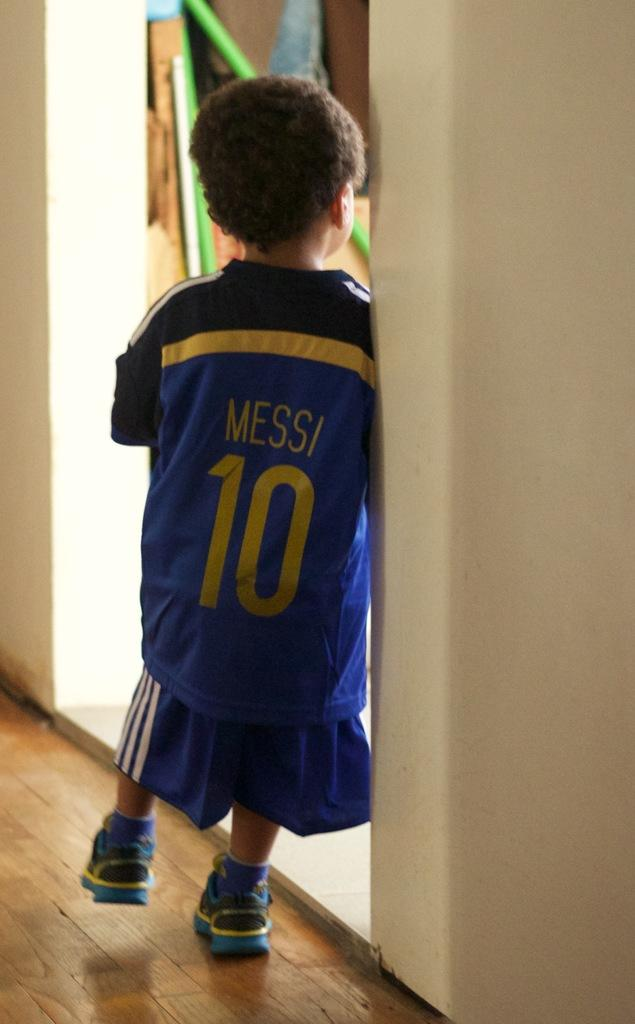<image>
Give a short and clear explanation of the subsequent image. A little kid wears the number 10 jersey with the name Messi. 